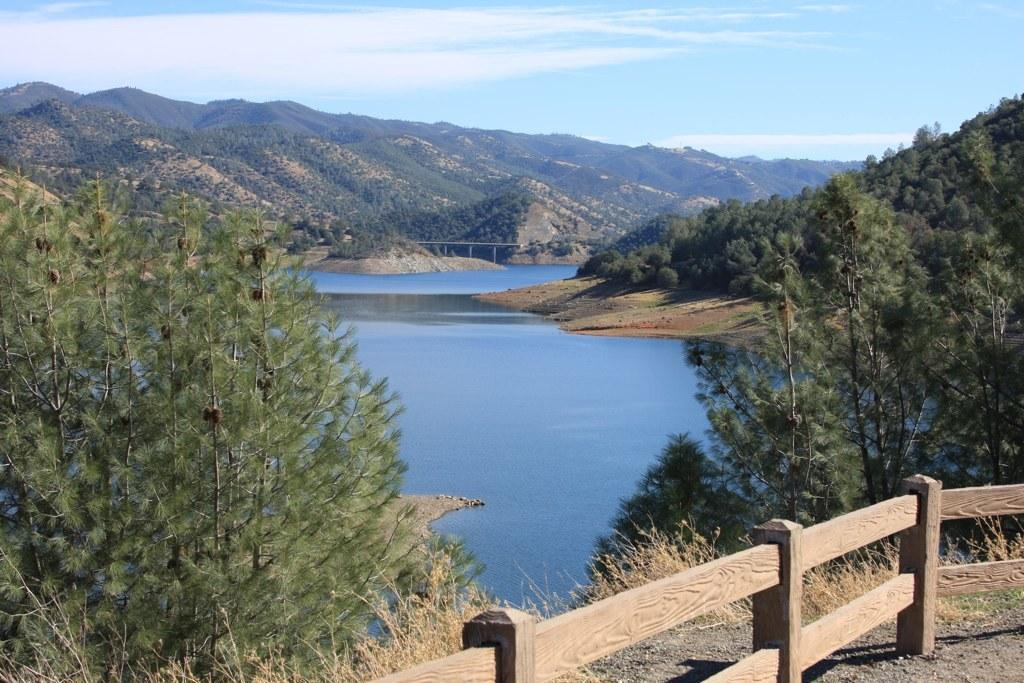What can be seen in the image that covers the ground? There is grass in the image that covers the ground. What type of natural features are present in the image? There are trees and hills visible in the image. What is the purpose of the fence in the image? The purpose of the fence in the image is not specified, but it could be used for marking boundaries or keeping animals in or out. What is visible in the sky in the image? The sky is visible in the image, and clouds are present. What does the mom do to the bell in the image? There is no mom or bell present in the image. 